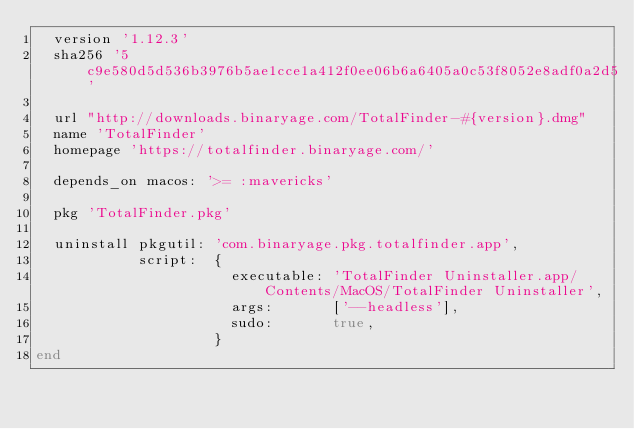<code> <loc_0><loc_0><loc_500><loc_500><_Ruby_>  version '1.12.3'
  sha256 '5c9e580d5d536b3976b5ae1cce1a412f0ee06b6a6405a0c53f8052e8adf0a2d5'

  url "http://downloads.binaryage.com/TotalFinder-#{version}.dmg"
  name 'TotalFinder'
  homepage 'https://totalfinder.binaryage.com/'

  depends_on macos: '>= :mavericks'

  pkg 'TotalFinder.pkg'

  uninstall pkgutil: 'com.binaryage.pkg.totalfinder.app',
            script:  {
                       executable: 'TotalFinder Uninstaller.app/Contents/MacOS/TotalFinder Uninstaller',
                       args:       ['--headless'],
                       sudo:       true,
                     }
end
</code> 